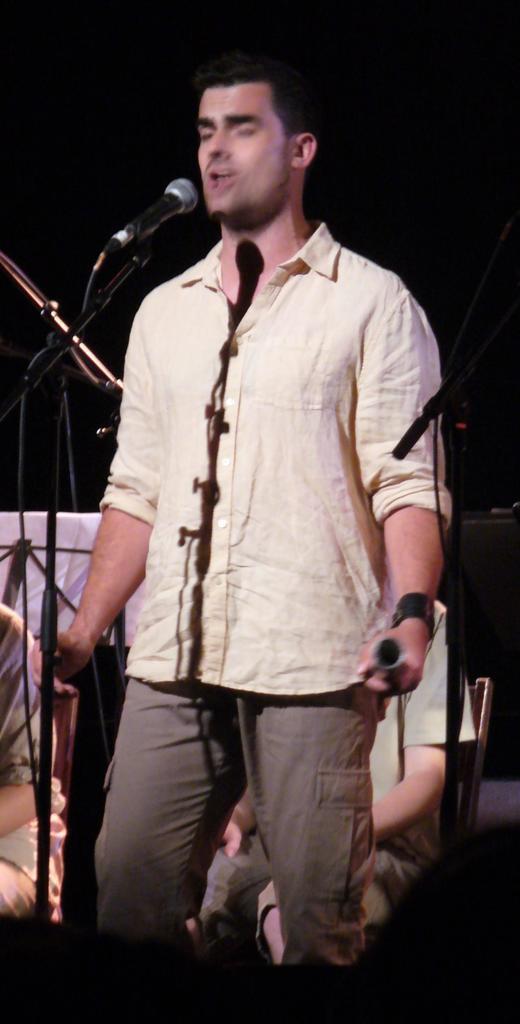Could you give a brief overview of what you see in this image? Background portion of the picture is completely dark. Few objects and people are viable. In this picture we can see a man wearing a shirt, holding an object and standing. It looks like he is singing. We can see stand, wires and a microphone. 